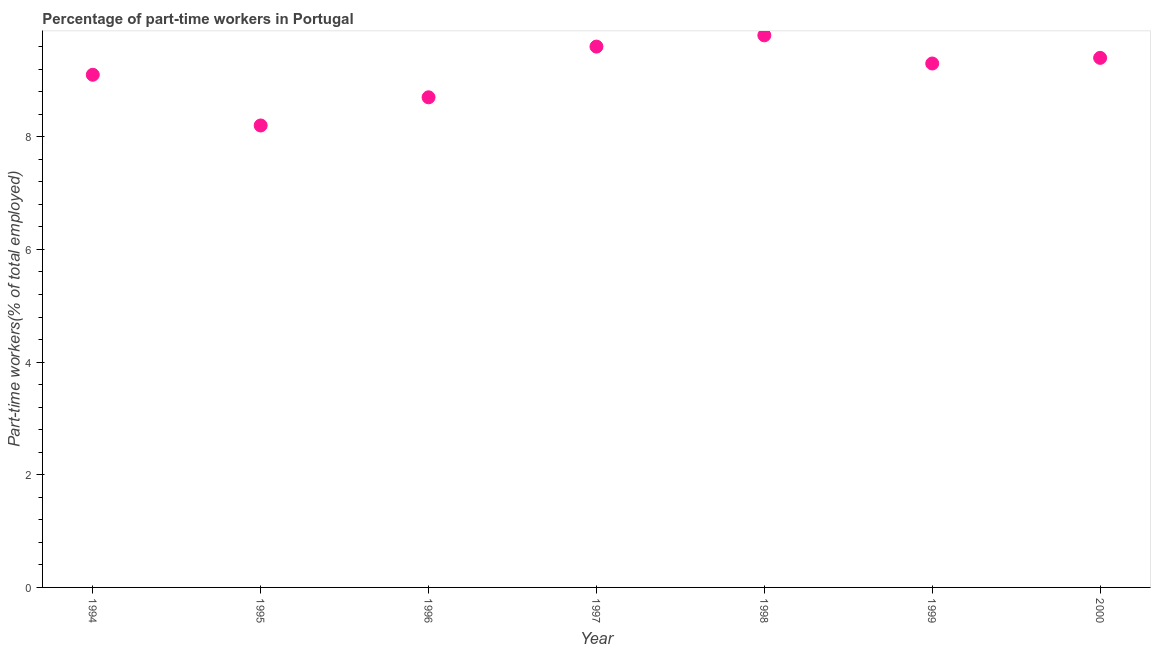What is the percentage of part-time workers in 1999?
Your answer should be very brief. 9.3. Across all years, what is the maximum percentage of part-time workers?
Keep it short and to the point. 9.8. Across all years, what is the minimum percentage of part-time workers?
Make the answer very short. 8.2. In which year was the percentage of part-time workers minimum?
Make the answer very short. 1995. What is the sum of the percentage of part-time workers?
Your response must be concise. 64.1. What is the difference between the percentage of part-time workers in 1998 and 1999?
Provide a succinct answer. 0.5. What is the average percentage of part-time workers per year?
Give a very brief answer. 9.16. What is the median percentage of part-time workers?
Your response must be concise. 9.3. Do a majority of the years between 2000 and 1994 (inclusive) have percentage of part-time workers greater than 6.4 %?
Offer a terse response. Yes. What is the ratio of the percentage of part-time workers in 1994 to that in 1998?
Provide a succinct answer. 0.93. Is the percentage of part-time workers in 1995 less than that in 1997?
Provide a succinct answer. Yes. What is the difference between the highest and the second highest percentage of part-time workers?
Your response must be concise. 0.2. Is the sum of the percentage of part-time workers in 1998 and 2000 greater than the maximum percentage of part-time workers across all years?
Offer a terse response. Yes. What is the difference between the highest and the lowest percentage of part-time workers?
Offer a terse response. 1.6. Does the percentage of part-time workers monotonically increase over the years?
Provide a succinct answer. No. How many years are there in the graph?
Make the answer very short. 7. What is the difference between two consecutive major ticks on the Y-axis?
Provide a short and direct response. 2. Does the graph contain grids?
Offer a terse response. No. What is the title of the graph?
Keep it short and to the point. Percentage of part-time workers in Portugal. What is the label or title of the Y-axis?
Provide a short and direct response. Part-time workers(% of total employed). What is the Part-time workers(% of total employed) in 1994?
Your answer should be very brief. 9.1. What is the Part-time workers(% of total employed) in 1995?
Provide a succinct answer. 8.2. What is the Part-time workers(% of total employed) in 1996?
Make the answer very short. 8.7. What is the Part-time workers(% of total employed) in 1997?
Give a very brief answer. 9.6. What is the Part-time workers(% of total employed) in 1998?
Make the answer very short. 9.8. What is the Part-time workers(% of total employed) in 1999?
Your answer should be compact. 9.3. What is the Part-time workers(% of total employed) in 2000?
Offer a very short reply. 9.4. What is the difference between the Part-time workers(% of total employed) in 1994 and 1995?
Provide a succinct answer. 0.9. What is the difference between the Part-time workers(% of total employed) in 1994 and 1998?
Provide a succinct answer. -0.7. What is the difference between the Part-time workers(% of total employed) in 1995 and 1997?
Make the answer very short. -1.4. What is the difference between the Part-time workers(% of total employed) in 1995 and 1998?
Your response must be concise. -1.6. What is the difference between the Part-time workers(% of total employed) in 1996 and 1997?
Ensure brevity in your answer.  -0.9. What is the difference between the Part-time workers(% of total employed) in 1996 and 1998?
Your answer should be compact. -1.1. What is the difference between the Part-time workers(% of total employed) in 1996 and 2000?
Provide a succinct answer. -0.7. What is the difference between the Part-time workers(% of total employed) in 1997 and 1999?
Ensure brevity in your answer.  0.3. What is the difference between the Part-time workers(% of total employed) in 1997 and 2000?
Offer a terse response. 0.2. What is the ratio of the Part-time workers(% of total employed) in 1994 to that in 1995?
Offer a very short reply. 1.11. What is the ratio of the Part-time workers(% of total employed) in 1994 to that in 1996?
Provide a succinct answer. 1.05. What is the ratio of the Part-time workers(% of total employed) in 1994 to that in 1997?
Make the answer very short. 0.95. What is the ratio of the Part-time workers(% of total employed) in 1994 to that in 1998?
Provide a short and direct response. 0.93. What is the ratio of the Part-time workers(% of total employed) in 1994 to that in 1999?
Give a very brief answer. 0.98. What is the ratio of the Part-time workers(% of total employed) in 1994 to that in 2000?
Your answer should be compact. 0.97. What is the ratio of the Part-time workers(% of total employed) in 1995 to that in 1996?
Give a very brief answer. 0.94. What is the ratio of the Part-time workers(% of total employed) in 1995 to that in 1997?
Keep it short and to the point. 0.85. What is the ratio of the Part-time workers(% of total employed) in 1995 to that in 1998?
Your answer should be very brief. 0.84. What is the ratio of the Part-time workers(% of total employed) in 1995 to that in 1999?
Provide a short and direct response. 0.88. What is the ratio of the Part-time workers(% of total employed) in 1995 to that in 2000?
Offer a very short reply. 0.87. What is the ratio of the Part-time workers(% of total employed) in 1996 to that in 1997?
Your answer should be very brief. 0.91. What is the ratio of the Part-time workers(% of total employed) in 1996 to that in 1998?
Your answer should be compact. 0.89. What is the ratio of the Part-time workers(% of total employed) in 1996 to that in 1999?
Give a very brief answer. 0.94. What is the ratio of the Part-time workers(% of total employed) in 1996 to that in 2000?
Provide a succinct answer. 0.93. What is the ratio of the Part-time workers(% of total employed) in 1997 to that in 1998?
Provide a succinct answer. 0.98. What is the ratio of the Part-time workers(% of total employed) in 1997 to that in 1999?
Keep it short and to the point. 1.03. What is the ratio of the Part-time workers(% of total employed) in 1998 to that in 1999?
Offer a terse response. 1.05. What is the ratio of the Part-time workers(% of total employed) in 1998 to that in 2000?
Offer a very short reply. 1.04. What is the ratio of the Part-time workers(% of total employed) in 1999 to that in 2000?
Give a very brief answer. 0.99. 